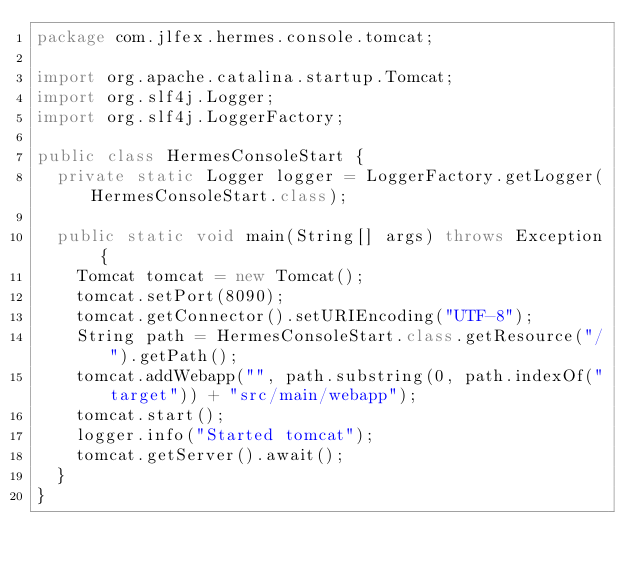Convert code to text. <code><loc_0><loc_0><loc_500><loc_500><_Java_>package com.jlfex.hermes.console.tomcat;

import org.apache.catalina.startup.Tomcat;
import org.slf4j.Logger;
import org.slf4j.LoggerFactory;

public class HermesConsoleStart {
	private static Logger logger = LoggerFactory.getLogger(HermesConsoleStart.class);

	public static void main(String[] args) throws Exception {
		Tomcat tomcat = new Tomcat();
		tomcat.setPort(8090);
		tomcat.getConnector().setURIEncoding("UTF-8");
		String path = HermesConsoleStart.class.getResource("/").getPath();
		tomcat.addWebapp("", path.substring(0, path.indexOf("target")) + "src/main/webapp");
		tomcat.start();
		logger.info("Started tomcat");
		tomcat.getServer().await();
	}
}</code> 